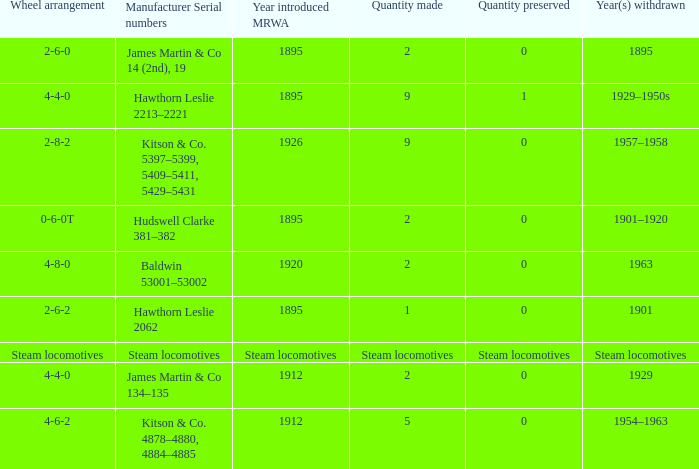What is the manufacturer serial number of the 1963 withdrawn year? Baldwin 53001–53002. 